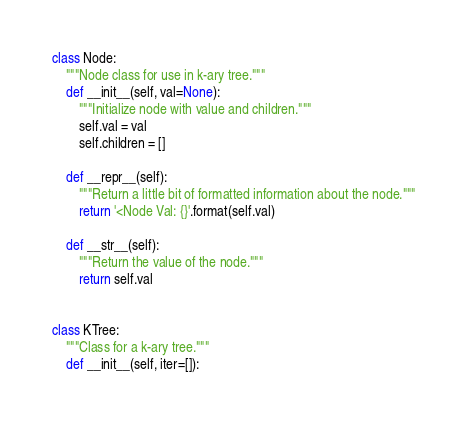<code> <loc_0><loc_0><loc_500><loc_500><_Python_>class Node:
    """Node class for use in k-ary tree."""
    def __init__(self, val=None):
        """Initialize node with value and children."""
        self.val = val
        self.children = []

    def __repr__(self):
        """Return a little bit of formatted information about the node."""
        return '<Node Val: {}'.format(self.val)

    def __str__(self):
        """Return the value of the node."""
        return self.val


class KTree:
    """Class for a k-ary tree."""
    def __init__(self, iter=[]):</code> 